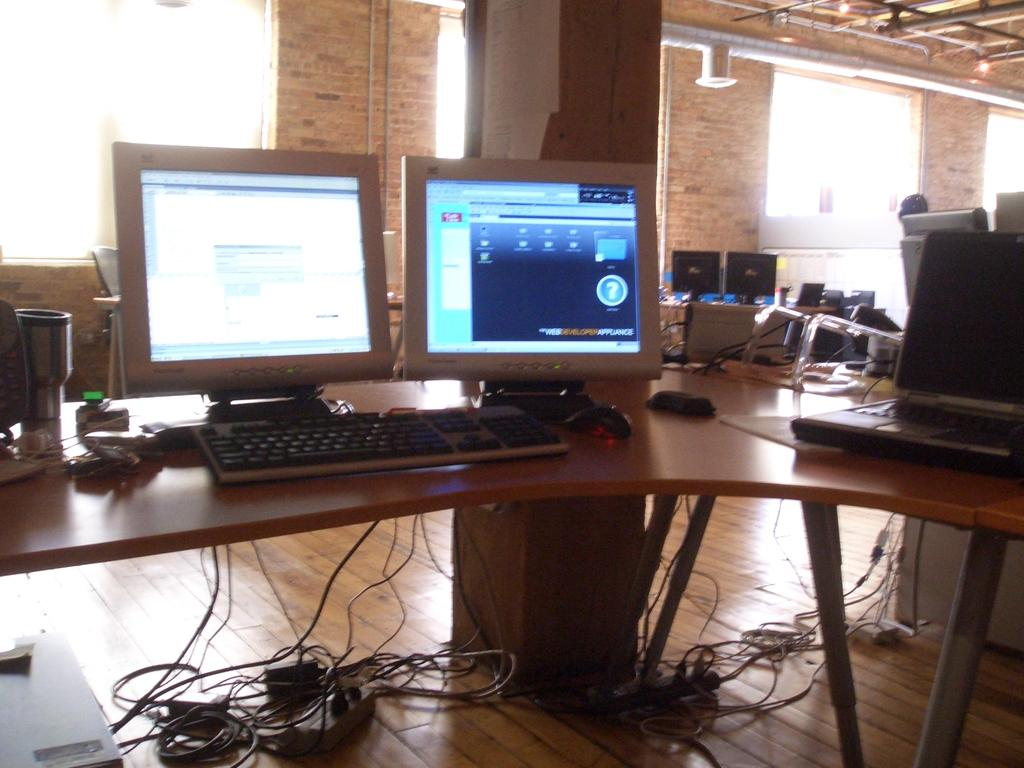What type of structure is visible in the image? There is a brick wall in the image. What architectural feature can be seen in the brick wall? There is a window in the image. What type of furniture is present in the image? There are tables in the image. What electronic devices are on the tables? There are screens and keyboards on the tables. What type of input device is on the tables? Mice are on the tables. What else can be seen on the tables? There are papers on the tables. Can you see a robin perched on the brick wall in the image? No, there is no robin present in the image. Is there a source of water visible in the image? No, there is no water visible in the image. 